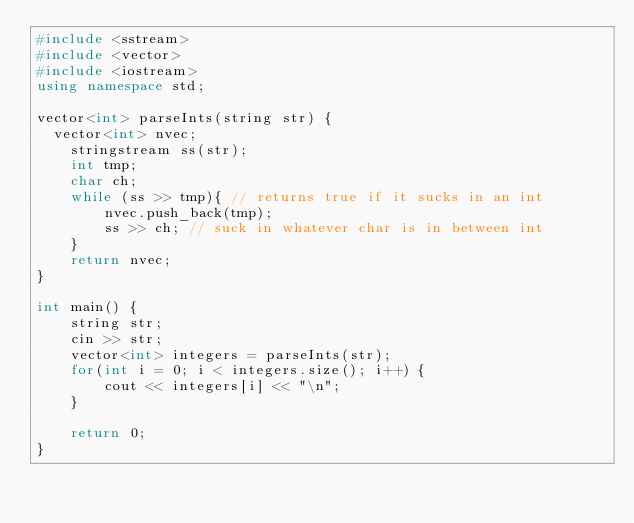Convert code to text. <code><loc_0><loc_0><loc_500><loc_500><_C++_>#include <sstream>
#include <vector>
#include <iostream>
using namespace std;

vector<int> parseInts(string str) {
	vector<int> nvec;
    stringstream ss(str);
    int tmp;
    char ch;
    while (ss >> tmp){ // returns true if it sucks in an int
        nvec.push_back(tmp);
        ss >> ch; // suck in whatever char is in between int
    }
    return nvec;
}

int main() {
    string str;
    cin >> str;
    vector<int> integers = parseInts(str);
    for(int i = 0; i < integers.size(); i++) {
        cout << integers[i] << "\n";
    }
    
    return 0;
}</code> 